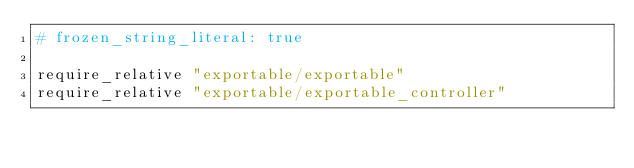Convert code to text. <code><loc_0><loc_0><loc_500><loc_500><_Ruby_># frozen_string_literal: true

require_relative "exportable/exportable"
require_relative "exportable/exportable_controller"
</code> 